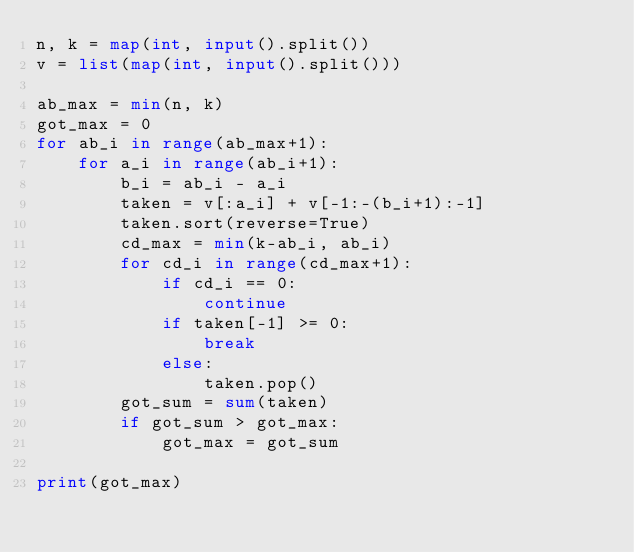Convert code to text. <code><loc_0><loc_0><loc_500><loc_500><_Python_>n, k = map(int, input().split())
v = list(map(int, input().split()))

ab_max = min(n, k)
got_max = 0
for ab_i in range(ab_max+1):
    for a_i in range(ab_i+1):
        b_i = ab_i - a_i
        taken = v[:a_i] + v[-1:-(b_i+1):-1]
        taken.sort(reverse=True)
        cd_max = min(k-ab_i, ab_i)
        for cd_i in range(cd_max+1):
            if cd_i == 0:
                continue
            if taken[-1] >= 0:
                break
            else:
                taken.pop()
        got_sum = sum(taken)
        if got_sum > got_max:
            got_max = got_sum

print(got_max)
</code> 